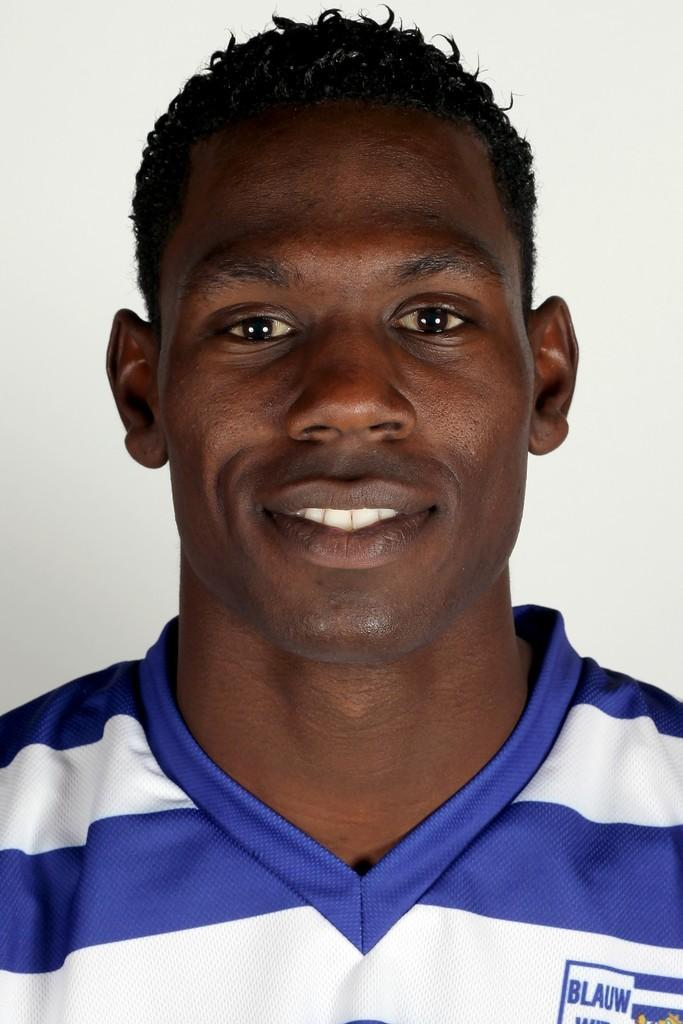<image>
Present a compact description of the photo's key features. The label on a smiling young man's striped shirt reads BLAUW. 